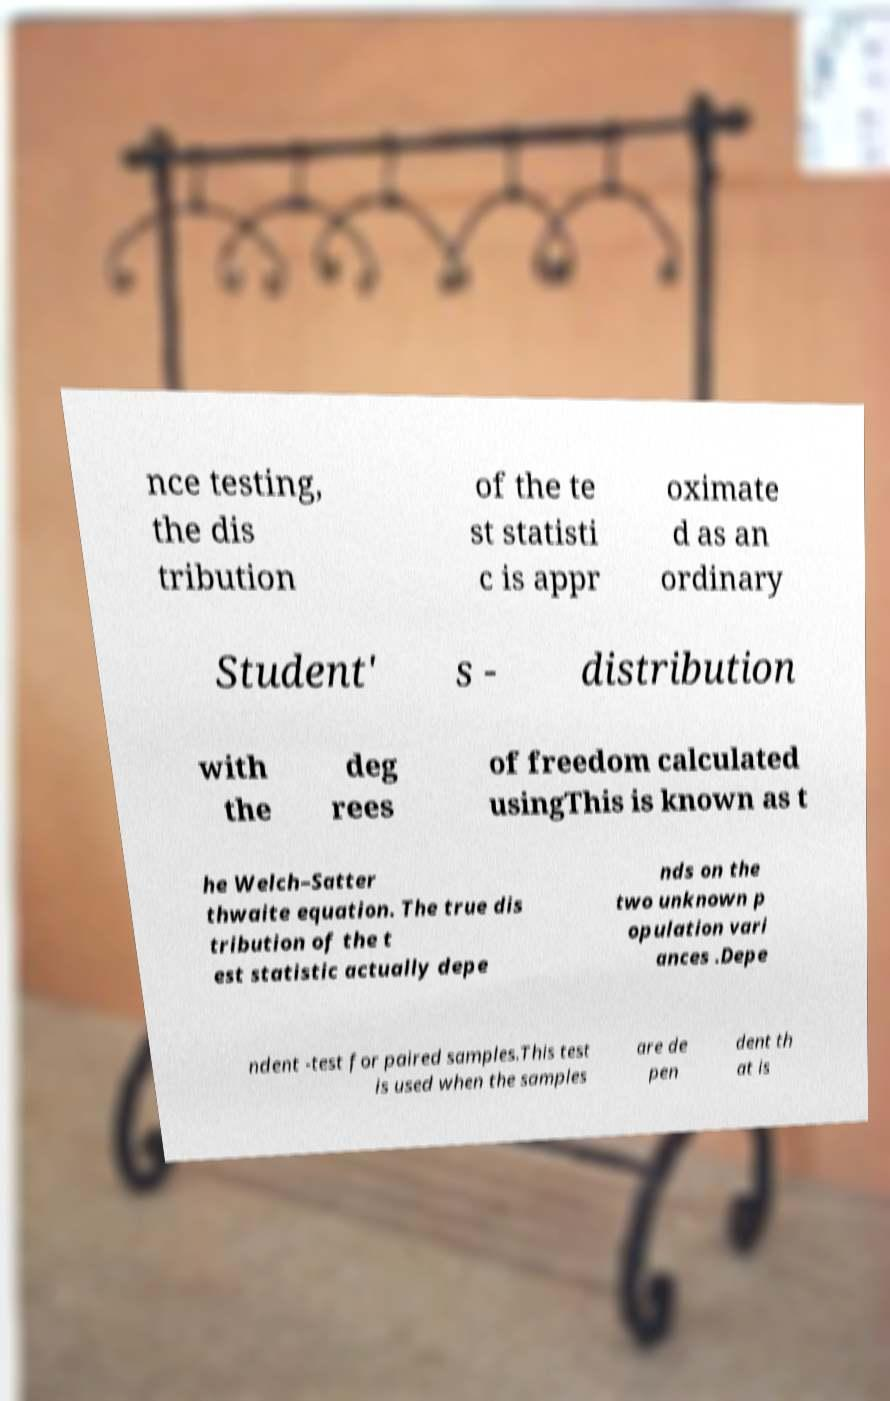Can you read and provide the text displayed in the image?This photo seems to have some interesting text. Can you extract and type it out for me? nce testing, the dis tribution of the te st statisti c is appr oximate d as an ordinary Student' s - distribution with the deg rees of freedom calculated usingThis is known as t he Welch–Satter thwaite equation. The true dis tribution of the t est statistic actually depe nds on the two unknown p opulation vari ances .Depe ndent -test for paired samples.This test is used when the samples are de pen dent th at is 